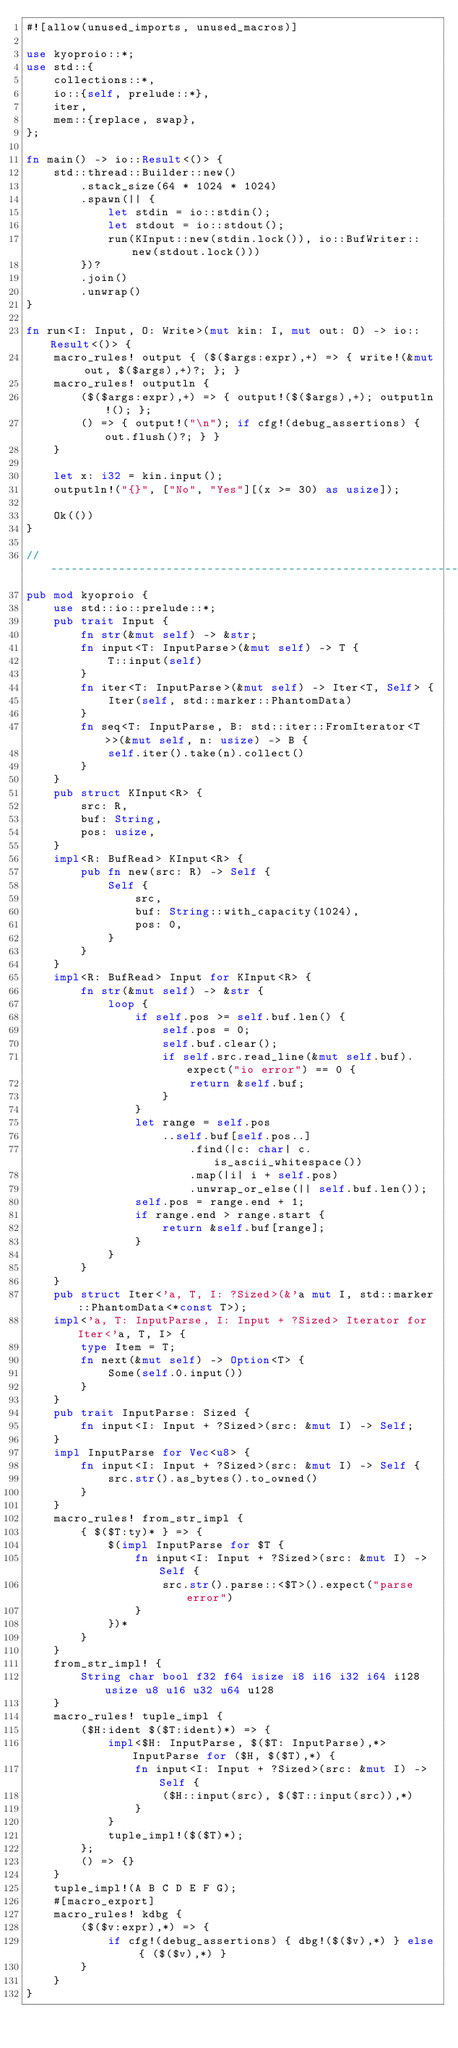Convert code to text. <code><loc_0><loc_0><loc_500><loc_500><_Rust_>#![allow(unused_imports, unused_macros)]

use kyoproio::*;
use std::{
    collections::*,
    io::{self, prelude::*},
    iter,
    mem::{replace, swap},
};

fn main() -> io::Result<()> {
    std::thread::Builder::new()
        .stack_size(64 * 1024 * 1024)
        .spawn(|| {
            let stdin = io::stdin();
            let stdout = io::stdout();
            run(KInput::new(stdin.lock()), io::BufWriter::new(stdout.lock()))
        })?
        .join()
        .unwrap()
}

fn run<I: Input, O: Write>(mut kin: I, mut out: O) -> io::Result<()> {
    macro_rules! output { ($($args:expr),+) => { write!(&mut out, $($args),+)?; }; }
    macro_rules! outputln {
        ($($args:expr),+) => { output!($($args),+); outputln!(); };
        () => { output!("\n"); if cfg!(debug_assertions) { out.flush()?; } }
    }

    let x: i32 = kin.input();
    outputln!("{}", ["No", "Yes"][(x >= 30) as usize]);

    Ok(())
}

// -----------------------------------------------------------------------------
pub mod kyoproio {
    use std::io::prelude::*;
    pub trait Input {
        fn str(&mut self) -> &str;
        fn input<T: InputParse>(&mut self) -> T {
            T::input(self)
        }
        fn iter<T: InputParse>(&mut self) -> Iter<T, Self> {
            Iter(self, std::marker::PhantomData)
        }
        fn seq<T: InputParse, B: std::iter::FromIterator<T>>(&mut self, n: usize) -> B {
            self.iter().take(n).collect()
        }
    }
    pub struct KInput<R> {
        src: R,
        buf: String,
        pos: usize,
    }
    impl<R: BufRead> KInput<R> {
        pub fn new(src: R) -> Self {
            Self {
                src,
                buf: String::with_capacity(1024),
                pos: 0,
            }
        }
    }
    impl<R: BufRead> Input for KInput<R> {
        fn str(&mut self) -> &str {
            loop {
                if self.pos >= self.buf.len() {
                    self.pos = 0;
                    self.buf.clear();
                    if self.src.read_line(&mut self.buf).expect("io error") == 0 {
                        return &self.buf;
                    }
                }
                let range = self.pos
                    ..self.buf[self.pos..]
                        .find(|c: char| c.is_ascii_whitespace())
                        .map(|i| i + self.pos)
                        .unwrap_or_else(|| self.buf.len());
                self.pos = range.end + 1;
                if range.end > range.start {
                    return &self.buf[range];
                }
            }
        }
    }
    pub struct Iter<'a, T, I: ?Sized>(&'a mut I, std::marker::PhantomData<*const T>);
    impl<'a, T: InputParse, I: Input + ?Sized> Iterator for Iter<'a, T, I> {
        type Item = T;
        fn next(&mut self) -> Option<T> {
            Some(self.0.input())
        }
    }
    pub trait InputParse: Sized {
        fn input<I: Input + ?Sized>(src: &mut I) -> Self;
    }
    impl InputParse for Vec<u8> {
        fn input<I: Input + ?Sized>(src: &mut I) -> Self {
            src.str().as_bytes().to_owned()
        }
    }
    macro_rules! from_str_impl {
        { $($T:ty)* } => {
            $(impl InputParse for $T {
                fn input<I: Input + ?Sized>(src: &mut I) -> Self {
                    src.str().parse::<$T>().expect("parse error")
                }
            })*
        }
    }
    from_str_impl! {
        String char bool f32 f64 isize i8 i16 i32 i64 i128 usize u8 u16 u32 u64 u128
    }
    macro_rules! tuple_impl {
        ($H:ident $($T:ident)*) => {
            impl<$H: InputParse, $($T: InputParse),*> InputParse for ($H, $($T),*) {
                fn input<I: Input + ?Sized>(src: &mut I) -> Self {
                    ($H::input(src), $($T::input(src)),*)
                }
            }
            tuple_impl!($($T)*);
        };
        () => {}
    }
    tuple_impl!(A B C D E F G);
    #[macro_export]
    macro_rules! kdbg {
        ($($v:expr),*) => {
            if cfg!(debug_assertions) { dbg!($($v),*) } else { ($($v),*) }
        }
    }
}
</code> 